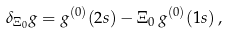<formula> <loc_0><loc_0><loc_500><loc_500>\delta _ { \Xi _ { 0 } } g = g ^ { ( 0 ) } ( 2 s ) - \Xi _ { 0 } \, g ^ { ( 0 ) } ( 1 s ) \, ,</formula> 